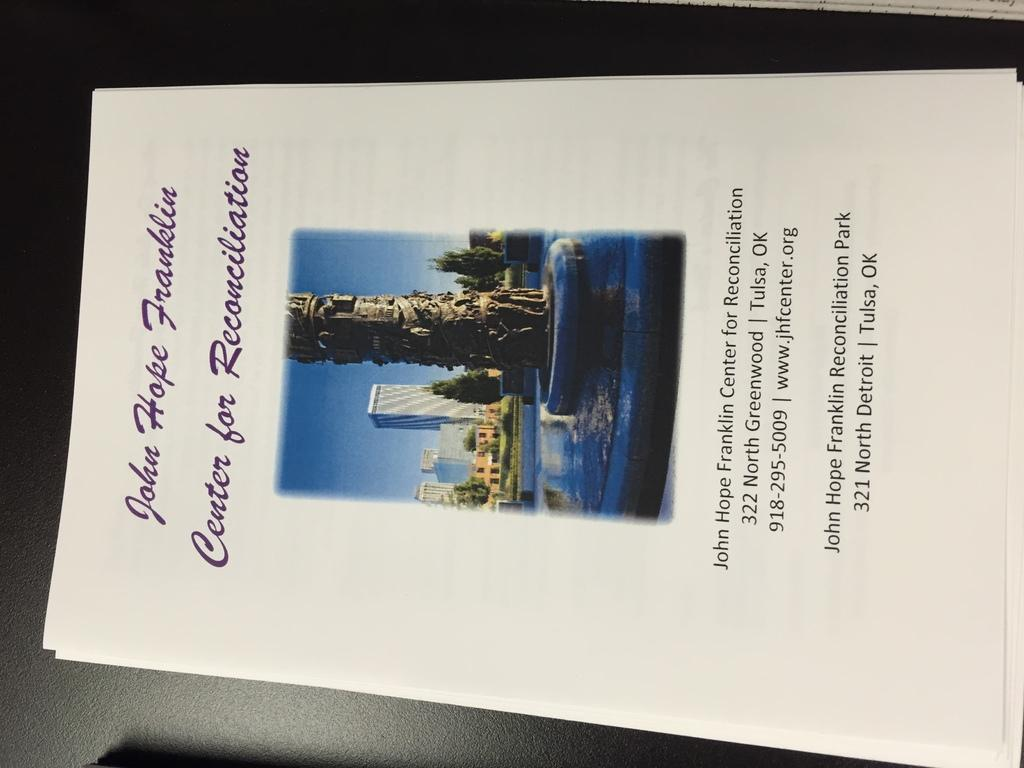<image>
Create a compact narrative representing the image presented. Flyer advertising the John Hope Franklin Center for Reconciliation. 